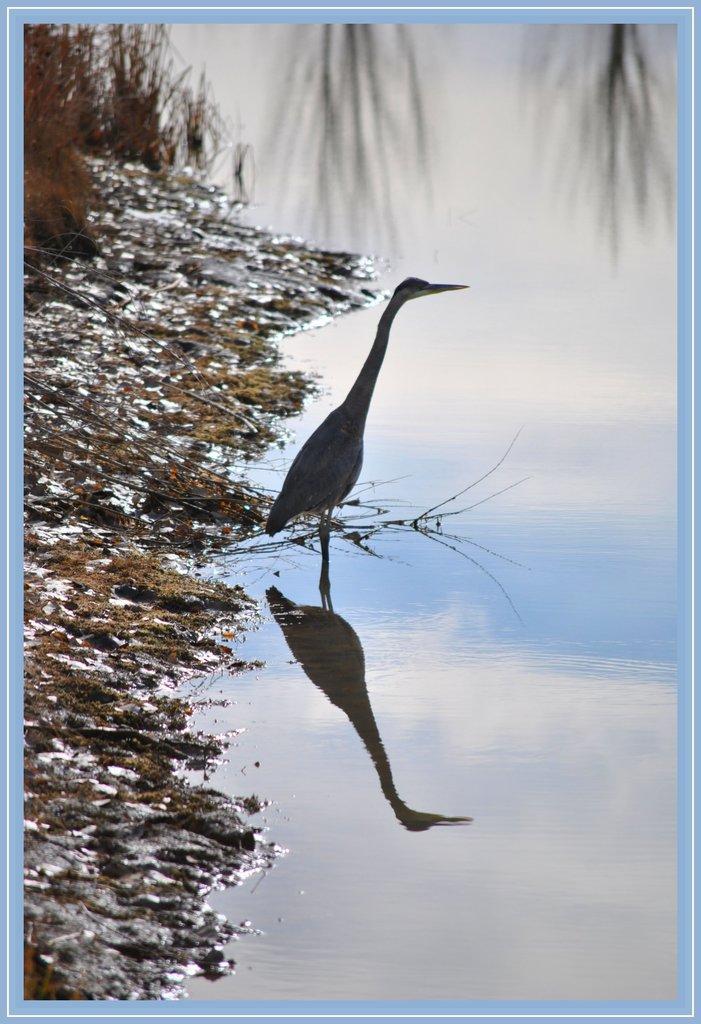How would you summarize this image in a sentence or two? In this image, we can see a photo frame. In the middle of the image, we can see a bird which is on the water. On the left side, we can see some grass and plants. At the top, we can see some trees, at the bottom, we can see a mirror image of a bird and a sky. 